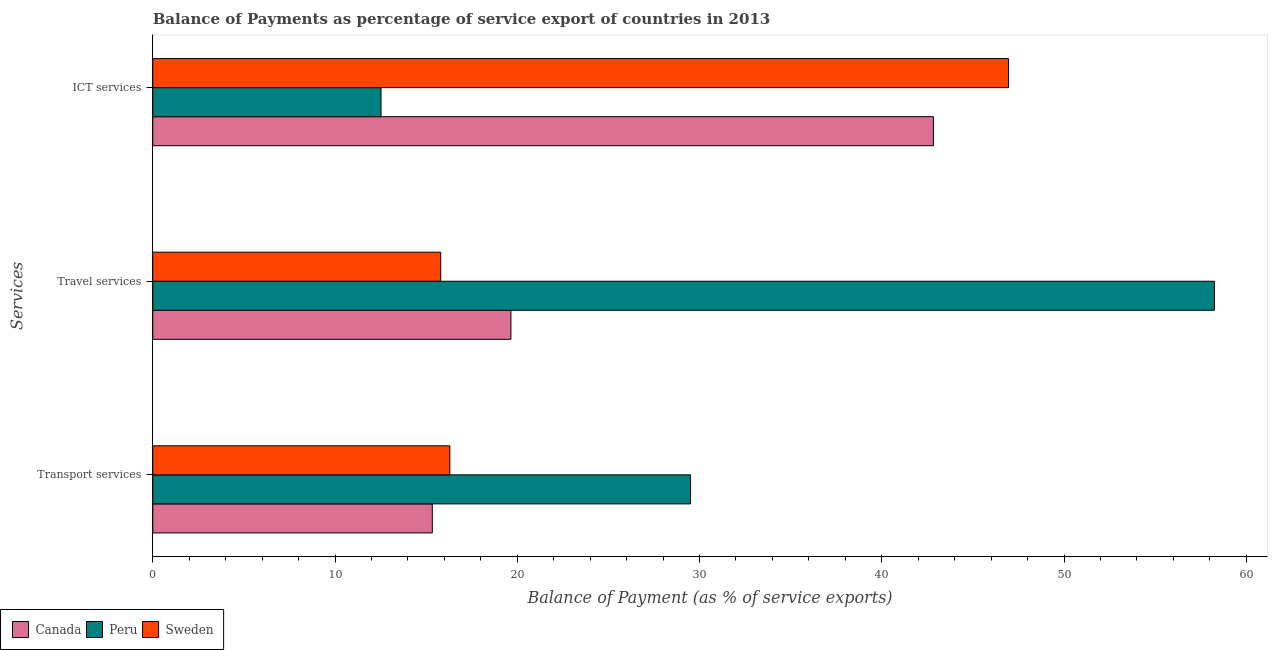Are the number of bars per tick equal to the number of legend labels?
Ensure brevity in your answer.  Yes. How many bars are there on the 2nd tick from the bottom?
Keep it short and to the point. 3. What is the label of the 1st group of bars from the top?
Provide a succinct answer. ICT services. What is the balance of payment of transport services in Sweden?
Your answer should be compact. 16.3. Across all countries, what is the maximum balance of payment of ict services?
Offer a very short reply. 46.95. Across all countries, what is the minimum balance of payment of travel services?
Keep it short and to the point. 15.8. In which country was the balance of payment of transport services minimum?
Ensure brevity in your answer.  Canada. What is the total balance of payment of travel services in the graph?
Your answer should be compact. 93.7. What is the difference between the balance of payment of ict services in Canada and that in Sweden?
Offer a terse response. -4.12. What is the difference between the balance of payment of transport services in Canada and the balance of payment of ict services in Peru?
Provide a succinct answer. 2.81. What is the average balance of payment of ict services per country?
Provide a short and direct response. 34.1. What is the difference between the balance of payment of transport services and balance of payment of travel services in Sweden?
Give a very brief answer. 0.5. In how many countries, is the balance of payment of transport services greater than 24 %?
Your response must be concise. 1. What is the ratio of the balance of payment of ict services in Sweden to that in Peru?
Your answer should be compact. 3.75. What is the difference between the highest and the second highest balance of payment of travel services?
Offer a terse response. 38.6. What is the difference between the highest and the lowest balance of payment of travel services?
Ensure brevity in your answer.  42.45. Is the sum of the balance of payment of ict services in Sweden and Canada greater than the maximum balance of payment of travel services across all countries?
Your answer should be compact. Yes. What does the 2nd bar from the bottom in Transport services represents?
Keep it short and to the point. Peru. Is it the case that in every country, the sum of the balance of payment of transport services and balance of payment of travel services is greater than the balance of payment of ict services?
Keep it short and to the point. No. How many bars are there?
Provide a short and direct response. 9. Are all the bars in the graph horizontal?
Your answer should be compact. Yes. What is the difference between two consecutive major ticks on the X-axis?
Your response must be concise. 10. Are the values on the major ticks of X-axis written in scientific E-notation?
Your response must be concise. No. Does the graph contain any zero values?
Give a very brief answer. No. How many legend labels are there?
Your answer should be compact. 3. How are the legend labels stacked?
Offer a very short reply. Horizontal. What is the title of the graph?
Provide a short and direct response. Balance of Payments as percentage of service export of countries in 2013. Does "Montenegro" appear as one of the legend labels in the graph?
Offer a terse response. No. What is the label or title of the X-axis?
Your answer should be very brief. Balance of Payment (as % of service exports). What is the label or title of the Y-axis?
Provide a succinct answer. Services. What is the Balance of Payment (as % of service exports) in Canada in Transport services?
Give a very brief answer. 15.34. What is the Balance of Payment (as % of service exports) of Peru in Transport services?
Provide a short and direct response. 29.51. What is the Balance of Payment (as % of service exports) in Sweden in Transport services?
Make the answer very short. 16.3. What is the Balance of Payment (as % of service exports) of Canada in Travel services?
Provide a succinct answer. 19.65. What is the Balance of Payment (as % of service exports) of Peru in Travel services?
Ensure brevity in your answer.  58.25. What is the Balance of Payment (as % of service exports) in Sweden in Travel services?
Your answer should be compact. 15.8. What is the Balance of Payment (as % of service exports) in Canada in ICT services?
Offer a terse response. 42.83. What is the Balance of Payment (as % of service exports) of Peru in ICT services?
Keep it short and to the point. 12.52. What is the Balance of Payment (as % of service exports) in Sweden in ICT services?
Offer a terse response. 46.95. Across all Services, what is the maximum Balance of Payment (as % of service exports) in Canada?
Make the answer very short. 42.83. Across all Services, what is the maximum Balance of Payment (as % of service exports) of Peru?
Your answer should be compact. 58.25. Across all Services, what is the maximum Balance of Payment (as % of service exports) in Sweden?
Provide a succinct answer. 46.95. Across all Services, what is the minimum Balance of Payment (as % of service exports) in Canada?
Give a very brief answer. 15.34. Across all Services, what is the minimum Balance of Payment (as % of service exports) in Peru?
Keep it short and to the point. 12.52. Across all Services, what is the minimum Balance of Payment (as % of service exports) of Sweden?
Your answer should be compact. 15.8. What is the total Balance of Payment (as % of service exports) of Canada in the graph?
Give a very brief answer. 77.82. What is the total Balance of Payment (as % of service exports) of Peru in the graph?
Your answer should be compact. 100.28. What is the total Balance of Payment (as % of service exports) of Sweden in the graph?
Your answer should be very brief. 79.05. What is the difference between the Balance of Payment (as % of service exports) of Canada in Transport services and that in Travel services?
Provide a short and direct response. -4.31. What is the difference between the Balance of Payment (as % of service exports) in Peru in Transport services and that in Travel services?
Offer a terse response. -28.74. What is the difference between the Balance of Payment (as % of service exports) in Sweden in Transport services and that in Travel services?
Give a very brief answer. 0.5. What is the difference between the Balance of Payment (as % of service exports) in Canada in Transport services and that in ICT services?
Your response must be concise. -27.5. What is the difference between the Balance of Payment (as % of service exports) in Peru in Transport services and that in ICT services?
Provide a short and direct response. 16.98. What is the difference between the Balance of Payment (as % of service exports) in Sweden in Transport services and that in ICT services?
Provide a succinct answer. -30.65. What is the difference between the Balance of Payment (as % of service exports) of Canada in Travel services and that in ICT services?
Give a very brief answer. -23.18. What is the difference between the Balance of Payment (as % of service exports) in Peru in Travel services and that in ICT services?
Make the answer very short. 45.73. What is the difference between the Balance of Payment (as % of service exports) in Sweden in Travel services and that in ICT services?
Your answer should be very brief. -31.15. What is the difference between the Balance of Payment (as % of service exports) of Canada in Transport services and the Balance of Payment (as % of service exports) of Peru in Travel services?
Your response must be concise. -42.91. What is the difference between the Balance of Payment (as % of service exports) of Canada in Transport services and the Balance of Payment (as % of service exports) of Sweden in Travel services?
Offer a very short reply. -0.46. What is the difference between the Balance of Payment (as % of service exports) of Peru in Transport services and the Balance of Payment (as % of service exports) of Sweden in Travel services?
Your answer should be compact. 13.71. What is the difference between the Balance of Payment (as % of service exports) in Canada in Transport services and the Balance of Payment (as % of service exports) in Peru in ICT services?
Your answer should be very brief. 2.81. What is the difference between the Balance of Payment (as % of service exports) in Canada in Transport services and the Balance of Payment (as % of service exports) in Sweden in ICT services?
Offer a very short reply. -31.62. What is the difference between the Balance of Payment (as % of service exports) in Peru in Transport services and the Balance of Payment (as % of service exports) in Sweden in ICT services?
Offer a terse response. -17.45. What is the difference between the Balance of Payment (as % of service exports) in Canada in Travel services and the Balance of Payment (as % of service exports) in Peru in ICT services?
Your response must be concise. 7.13. What is the difference between the Balance of Payment (as % of service exports) of Canada in Travel services and the Balance of Payment (as % of service exports) of Sweden in ICT services?
Offer a terse response. -27.3. What is the difference between the Balance of Payment (as % of service exports) in Peru in Travel services and the Balance of Payment (as % of service exports) in Sweden in ICT services?
Offer a very short reply. 11.3. What is the average Balance of Payment (as % of service exports) in Canada per Services?
Give a very brief answer. 25.94. What is the average Balance of Payment (as % of service exports) in Peru per Services?
Make the answer very short. 33.43. What is the average Balance of Payment (as % of service exports) of Sweden per Services?
Your answer should be very brief. 26.35. What is the difference between the Balance of Payment (as % of service exports) of Canada and Balance of Payment (as % of service exports) of Peru in Transport services?
Offer a terse response. -14.17. What is the difference between the Balance of Payment (as % of service exports) of Canada and Balance of Payment (as % of service exports) of Sweden in Transport services?
Your answer should be compact. -0.96. What is the difference between the Balance of Payment (as % of service exports) in Peru and Balance of Payment (as % of service exports) in Sweden in Transport services?
Your response must be concise. 13.21. What is the difference between the Balance of Payment (as % of service exports) of Canada and Balance of Payment (as % of service exports) of Peru in Travel services?
Your response must be concise. -38.6. What is the difference between the Balance of Payment (as % of service exports) of Canada and Balance of Payment (as % of service exports) of Sweden in Travel services?
Offer a terse response. 3.85. What is the difference between the Balance of Payment (as % of service exports) in Peru and Balance of Payment (as % of service exports) in Sweden in Travel services?
Your response must be concise. 42.45. What is the difference between the Balance of Payment (as % of service exports) of Canada and Balance of Payment (as % of service exports) of Peru in ICT services?
Your response must be concise. 30.31. What is the difference between the Balance of Payment (as % of service exports) in Canada and Balance of Payment (as % of service exports) in Sweden in ICT services?
Make the answer very short. -4.12. What is the difference between the Balance of Payment (as % of service exports) of Peru and Balance of Payment (as % of service exports) of Sweden in ICT services?
Your answer should be compact. -34.43. What is the ratio of the Balance of Payment (as % of service exports) of Canada in Transport services to that in Travel services?
Make the answer very short. 0.78. What is the ratio of the Balance of Payment (as % of service exports) in Peru in Transport services to that in Travel services?
Your response must be concise. 0.51. What is the ratio of the Balance of Payment (as % of service exports) in Sweden in Transport services to that in Travel services?
Your answer should be compact. 1.03. What is the ratio of the Balance of Payment (as % of service exports) in Canada in Transport services to that in ICT services?
Provide a succinct answer. 0.36. What is the ratio of the Balance of Payment (as % of service exports) in Peru in Transport services to that in ICT services?
Provide a short and direct response. 2.36. What is the ratio of the Balance of Payment (as % of service exports) of Sweden in Transport services to that in ICT services?
Your answer should be compact. 0.35. What is the ratio of the Balance of Payment (as % of service exports) of Canada in Travel services to that in ICT services?
Provide a short and direct response. 0.46. What is the ratio of the Balance of Payment (as % of service exports) in Peru in Travel services to that in ICT services?
Offer a terse response. 4.65. What is the ratio of the Balance of Payment (as % of service exports) of Sweden in Travel services to that in ICT services?
Provide a succinct answer. 0.34. What is the difference between the highest and the second highest Balance of Payment (as % of service exports) in Canada?
Ensure brevity in your answer.  23.18. What is the difference between the highest and the second highest Balance of Payment (as % of service exports) in Peru?
Offer a terse response. 28.74. What is the difference between the highest and the second highest Balance of Payment (as % of service exports) of Sweden?
Provide a short and direct response. 30.65. What is the difference between the highest and the lowest Balance of Payment (as % of service exports) of Canada?
Keep it short and to the point. 27.5. What is the difference between the highest and the lowest Balance of Payment (as % of service exports) in Peru?
Your answer should be very brief. 45.73. What is the difference between the highest and the lowest Balance of Payment (as % of service exports) in Sweden?
Ensure brevity in your answer.  31.15. 